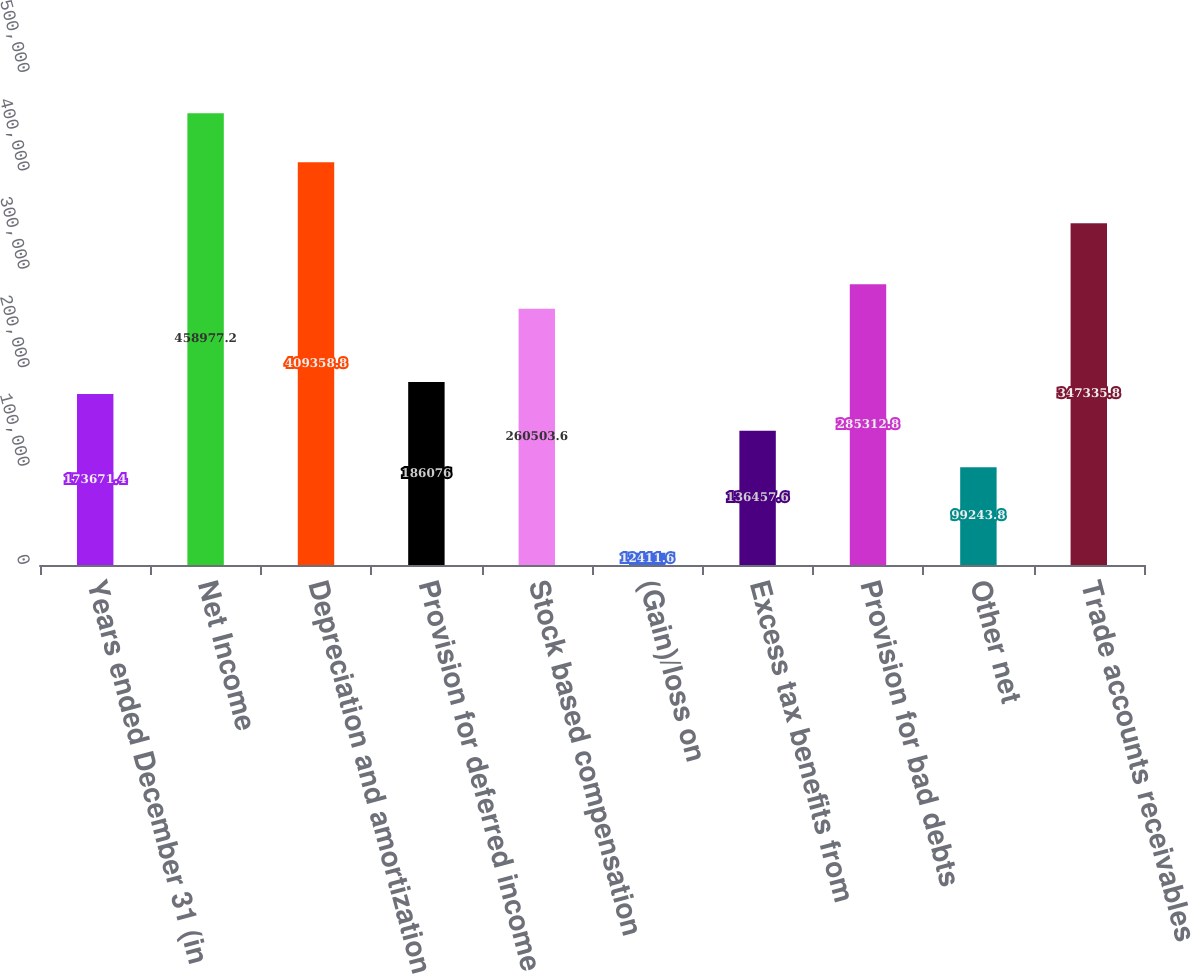<chart> <loc_0><loc_0><loc_500><loc_500><bar_chart><fcel>Years ended December 31 (in<fcel>Net Income<fcel>Depreciation and amortization<fcel>Provision for deferred income<fcel>Stock based compensation<fcel>(Gain)/loss on<fcel>Excess tax benefits from<fcel>Provision for bad debts<fcel>Other net<fcel>Trade accounts receivables<nl><fcel>173671<fcel>458977<fcel>409359<fcel>186076<fcel>260504<fcel>12411.6<fcel>136458<fcel>285313<fcel>99243.8<fcel>347336<nl></chart> 